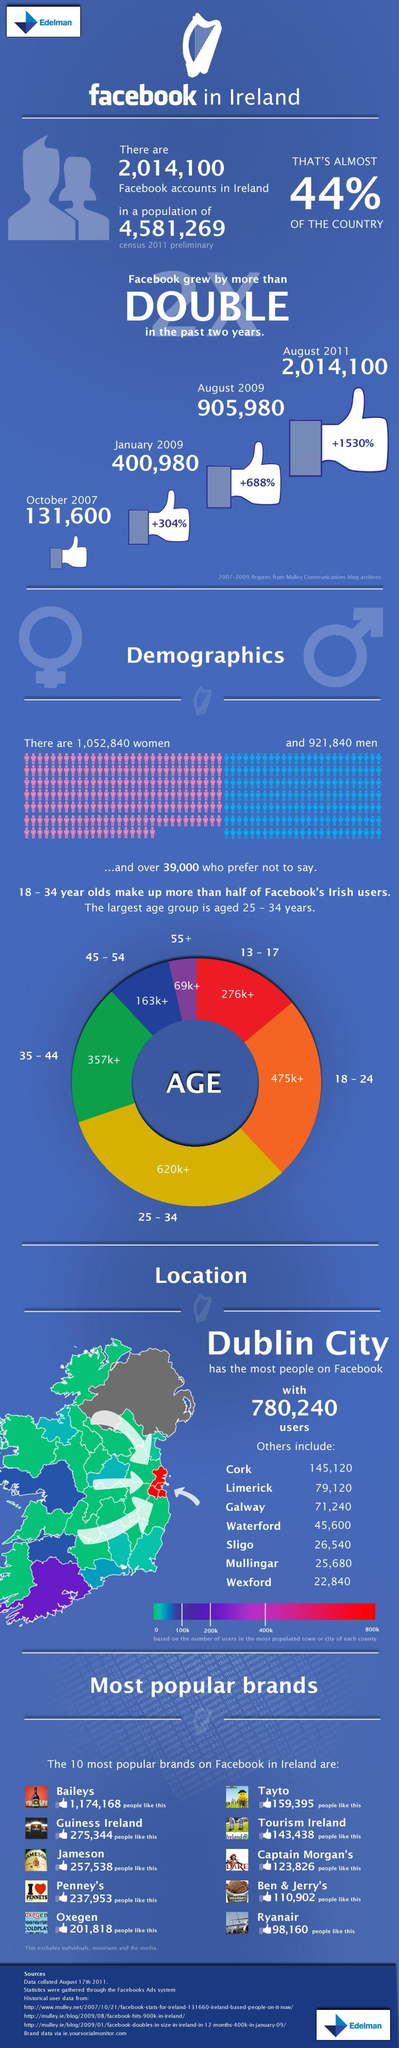By what percent did Facebook grow in August 2011?
Answer the question with a short phrase. +1530% How many senior citizens use Facebook? 69k+ Which gender has the majority in terms of users? women Which age group is denoted by orange colour? 18-24 About how many users make up the 25-34 age group? 620k+ Which colour represents 276k+ - red,green or blue? red 